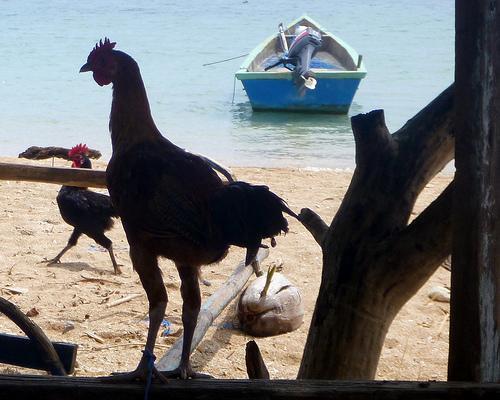How many chickens are there?
Give a very brief answer. 2. 